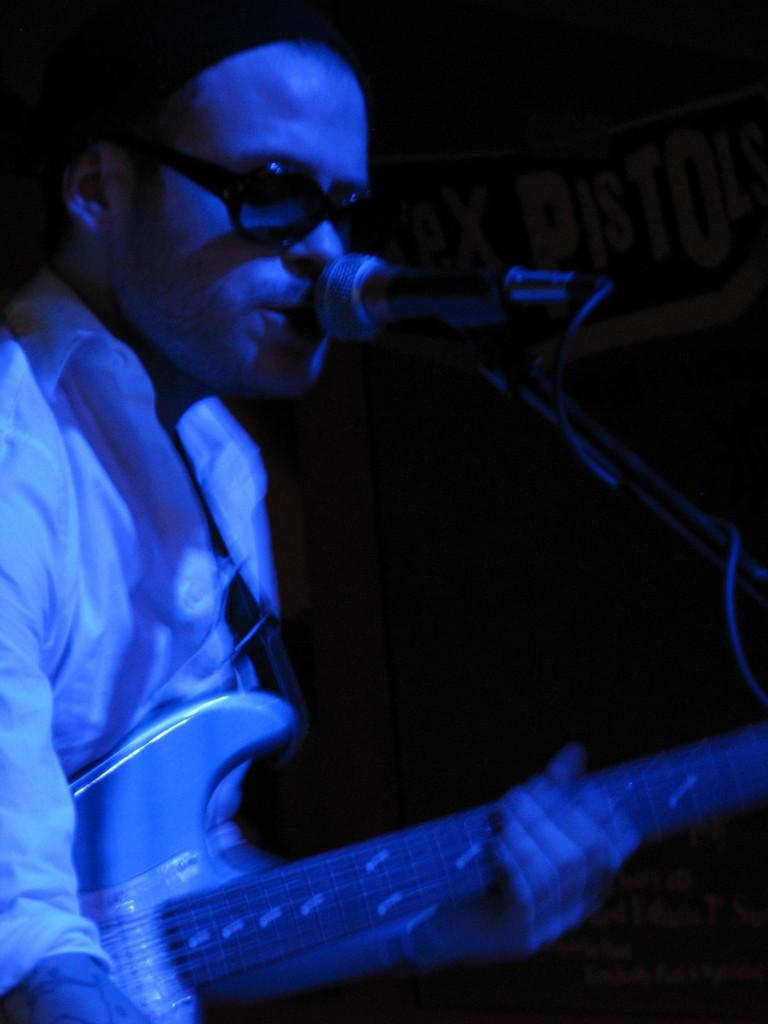What is the man in the image holding? The man is holding a guitar. What is the man doing with the guitar? The man is singing a song while holding the guitar. Can you describe the man's appearance? The man is wearing black spectacles. What can be seen in the background of the image? There is a banner and a black color wall in the background of the image. How many clocks are hanging on the wall behind the man? There are no clocks visible in the image. What type of pail is being used by the man to collect water in the image? There is no pail present in the image. 